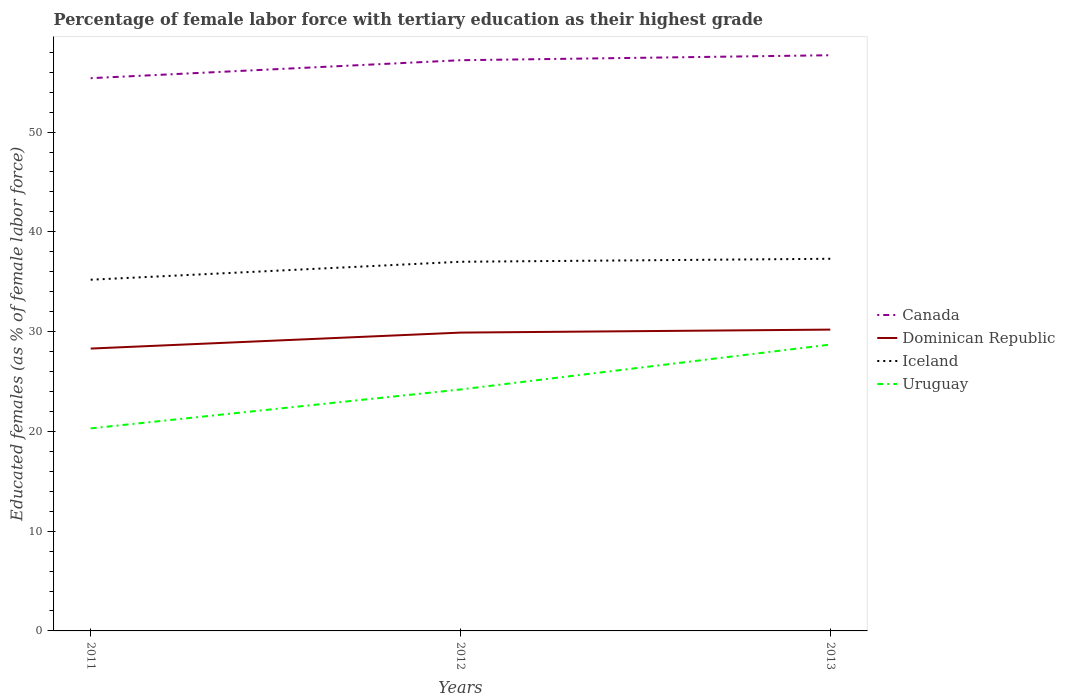How many different coloured lines are there?
Keep it short and to the point. 4. Is the number of lines equal to the number of legend labels?
Give a very brief answer. Yes. Across all years, what is the maximum percentage of female labor force with tertiary education in Canada?
Your answer should be compact. 55.4. In which year was the percentage of female labor force with tertiary education in Dominican Republic maximum?
Give a very brief answer. 2011. What is the total percentage of female labor force with tertiary education in Uruguay in the graph?
Your answer should be very brief. -8.4. What is the difference between the highest and the second highest percentage of female labor force with tertiary education in Uruguay?
Provide a succinct answer. 8.4. How many years are there in the graph?
Offer a very short reply. 3. What is the difference between two consecutive major ticks on the Y-axis?
Your answer should be compact. 10. Does the graph contain any zero values?
Make the answer very short. No. Does the graph contain grids?
Offer a terse response. No. How many legend labels are there?
Give a very brief answer. 4. How are the legend labels stacked?
Offer a terse response. Vertical. What is the title of the graph?
Offer a terse response. Percentage of female labor force with tertiary education as their highest grade. What is the label or title of the X-axis?
Offer a terse response. Years. What is the label or title of the Y-axis?
Your answer should be very brief. Educated females (as % of female labor force). What is the Educated females (as % of female labor force) of Canada in 2011?
Provide a short and direct response. 55.4. What is the Educated females (as % of female labor force) of Dominican Republic in 2011?
Offer a terse response. 28.3. What is the Educated females (as % of female labor force) in Iceland in 2011?
Give a very brief answer. 35.2. What is the Educated females (as % of female labor force) of Uruguay in 2011?
Keep it short and to the point. 20.3. What is the Educated females (as % of female labor force) in Canada in 2012?
Make the answer very short. 57.2. What is the Educated females (as % of female labor force) of Dominican Republic in 2012?
Your answer should be compact. 29.9. What is the Educated females (as % of female labor force) in Iceland in 2012?
Ensure brevity in your answer.  37. What is the Educated females (as % of female labor force) in Uruguay in 2012?
Ensure brevity in your answer.  24.2. What is the Educated females (as % of female labor force) in Canada in 2013?
Give a very brief answer. 57.7. What is the Educated females (as % of female labor force) of Dominican Republic in 2013?
Offer a terse response. 30.2. What is the Educated females (as % of female labor force) in Iceland in 2013?
Your response must be concise. 37.3. What is the Educated females (as % of female labor force) of Uruguay in 2013?
Keep it short and to the point. 28.7. Across all years, what is the maximum Educated females (as % of female labor force) of Canada?
Your answer should be very brief. 57.7. Across all years, what is the maximum Educated females (as % of female labor force) in Dominican Republic?
Your answer should be very brief. 30.2. Across all years, what is the maximum Educated females (as % of female labor force) in Iceland?
Give a very brief answer. 37.3. Across all years, what is the maximum Educated females (as % of female labor force) in Uruguay?
Offer a very short reply. 28.7. Across all years, what is the minimum Educated females (as % of female labor force) in Canada?
Provide a short and direct response. 55.4. Across all years, what is the minimum Educated females (as % of female labor force) in Dominican Republic?
Your response must be concise. 28.3. Across all years, what is the minimum Educated females (as % of female labor force) of Iceland?
Provide a succinct answer. 35.2. Across all years, what is the minimum Educated females (as % of female labor force) in Uruguay?
Give a very brief answer. 20.3. What is the total Educated females (as % of female labor force) in Canada in the graph?
Your answer should be very brief. 170.3. What is the total Educated females (as % of female labor force) of Dominican Republic in the graph?
Your response must be concise. 88.4. What is the total Educated females (as % of female labor force) in Iceland in the graph?
Provide a succinct answer. 109.5. What is the total Educated females (as % of female labor force) in Uruguay in the graph?
Give a very brief answer. 73.2. What is the difference between the Educated females (as % of female labor force) of Uruguay in 2011 and that in 2012?
Offer a terse response. -3.9. What is the difference between the Educated females (as % of female labor force) in Canada in 2011 and that in 2013?
Provide a short and direct response. -2.3. What is the difference between the Educated females (as % of female labor force) of Iceland in 2011 and that in 2013?
Keep it short and to the point. -2.1. What is the difference between the Educated females (as % of female labor force) in Uruguay in 2011 and that in 2013?
Provide a short and direct response. -8.4. What is the difference between the Educated females (as % of female labor force) of Dominican Republic in 2012 and that in 2013?
Make the answer very short. -0.3. What is the difference between the Educated females (as % of female labor force) in Iceland in 2012 and that in 2013?
Make the answer very short. -0.3. What is the difference between the Educated females (as % of female labor force) in Canada in 2011 and the Educated females (as % of female labor force) in Dominican Republic in 2012?
Make the answer very short. 25.5. What is the difference between the Educated females (as % of female labor force) of Canada in 2011 and the Educated females (as % of female labor force) of Uruguay in 2012?
Keep it short and to the point. 31.2. What is the difference between the Educated females (as % of female labor force) in Iceland in 2011 and the Educated females (as % of female labor force) in Uruguay in 2012?
Offer a terse response. 11. What is the difference between the Educated females (as % of female labor force) of Canada in 2011 and the Educated females (as % of female labor force) of Dominican Republic in 2013?
Your response must be concise. 25.2. What is the difference between the Educated females (as % of female labor force) of Canada in 2011 and the Educated females (as % of female labor force) of Uruguay in 2013?
Offer a very short reply. 26.7. What is the difference between the Educated females (as % of female labor force) of Dominican Republic in 2011 and the Educated females (as % of female labor force) of Iceland in 2013?
Offer a very short reply. -9. What is the difference between the Educated females (as % of female labor force) in Dominican Republic in 2011 and the Educated females (as % of female labor force) in Uruguay in 2013?
Your response must be concise. -0.4. What is the difference between the Educated females (as % of female labor force) of Iceland in 2011 and the Educated females (as % of female labor force) of Uruguay in 2013?
Offer a very short reply. 6.5. What is the difference between the Educated females (as % of female labor force) of Canada in 2012 and the Educated females (as % of female labor force) of Iceland in 2013?
Provide a short and direct response. 19.9. What is the average Educated females (as % of female labor force) of Canada per year?
Ensure brevity in your answer.  56.77. What is the average Educated females (as % of female labor force) of Dominican Republic per year?
Your response must be concise. 29.47. What is the average Educated females (as % of female labor force) in Iceland per year?
Provide a succinct answer. 36.5. What is the average Educated females (as % of female labor force) of Uruguay per year?
Make the answer very short. 24.4. In the year 2011, what is the difference between the Educated females (as % of female labor force) in Canada and Educated females (as % of female labor force) in Dominican Republic?
Provide a succinct answer. 27.1. In the year 2011, what is the difference between the Educated females (as % of female labor force) in Canada and Educated females (as % of female labor force) in Iceland?
Provide a succinct answer. 20.2. In the year 2011, what is the difference between the Educated females (as % of female labor force) of Canada and Educated females (as % of female labor force) of Uruguay?
Provide a short and direct response. 35.1. In the year 2011, what is the difference between the Educated females (as % of female labor force) of Dominican Republic and Educated females (as % of female labor force) of Uruguay?
Your response must be concise. 8. In the year 2012, what is the difference between the Educated females (as % of female labor force) in Canada and Educated females (as % of female labor force) in Dominican Republic?
Offer a very short reply. 27.3. In the year 2012, what is the difference between the Educated females (as % of female labor force) in Canada and Educated females (as % of female labor force) in Iceland?
Make the answer very short. 20.2. In the year 2012, what is the difference between the Educated females (as % of female labor force) of Canada and Educated females (as % of female labor force) of Uruguay?
Provide a short and direct response. 33. In the year 2012, what is the difference between the Educated females (as % of female labor force) in Dominican Republic and Educated females (as % of female labor force) in Iceland?
Make the answer very short. -7.1. In the year 2013, what is the difference between the Educated females (as % of female labor force) in Canada and Educated females (as % of female labor force) in Dominican Republic?
Your answer should be compact. 27.5. In the year 2013, what is the difference between the Educated females (as % of female labor force) of Canada and Educated females (as % of female labor force) of Iceland?
Offer a terse response. 20.4. In the year 2013, what is the difference between the Educated females (as % of female labor force) in Dominican Republic and Educated females (as % of female labor force) in Iceland?
Your answer should be compact. -7.1. What is the ratio of the Educated females (as % of female labor force) in Canada in 2011 to that in 2012?
Your response must be concise. 0.97. What is the ratio of the Educated females (as % of female labor force) of Dominican Republic in 2011 to that in 2012?
Your answer should be very brief. 0.95. What is the ratio of the Educated females (as % of female labor force) in Iceland in 2011 to that in 2012?
Provide a succinct answer. 0.95. What is the ratio of the Educated females (as % of female labor force) in Uruguay in 2011 to that in 2012?
Give a very brief answer. 0.84. What is the ratio of the Educated females (as % of female labor force) of Canada in 2011 to that in 2013?
Ensure brevity in your answer.  0.96. What is the ratio of the Educated females (as % of female labor force) in Dominican Republic in 2011 to that in 2013?
Make the answer very short. 0.94. What is the ratio of the Educated females (as % of female labor force) in Iceland in 2011 to that in 2013?
Your answer should be very brief. 0.94. What is the ratio of the Educated females (as % of female labor force) of Uruguay in 2011 to that in 2013?
Your answer should be very brief. 0.71. What is the ratio of the Educated females (as % of female labor force) in Dominican Republic in 2012 to that in 2013?
Provide a short and direct response. 0.99. What is the ratio of the Educated females (as % of female labor force) in Iceland in 2012 to that in 2013?
Provide a short and direct response. 0.99. What is the ratio of the Educated females (as % of female labor force) of Uruguay in 2012 to that in 2013?
Offer a very short reply. 0.84. What is the difference between the highest and the second highest Educated females (as % of female labor force) in Canada?
Offer a very short reply. 0.5. What is the difference between the highest and the second highest Educated females (as % of female labor force) in Iceland?
Offer a terse response. 0.3. What is the difference between the highest and the lowest Educated females (as % of female labor force) of Canada?
Give a very brief answer. 2.3. What is the difference between the highest and the lowest Educated females (as % of female labor force) of Dominican Republic?
Make the answer very short. 1.9. What is the difference between the highest and the lowest Educated females (as % of female labor force) of Iceland?
Offer a very short reply. 2.1. 